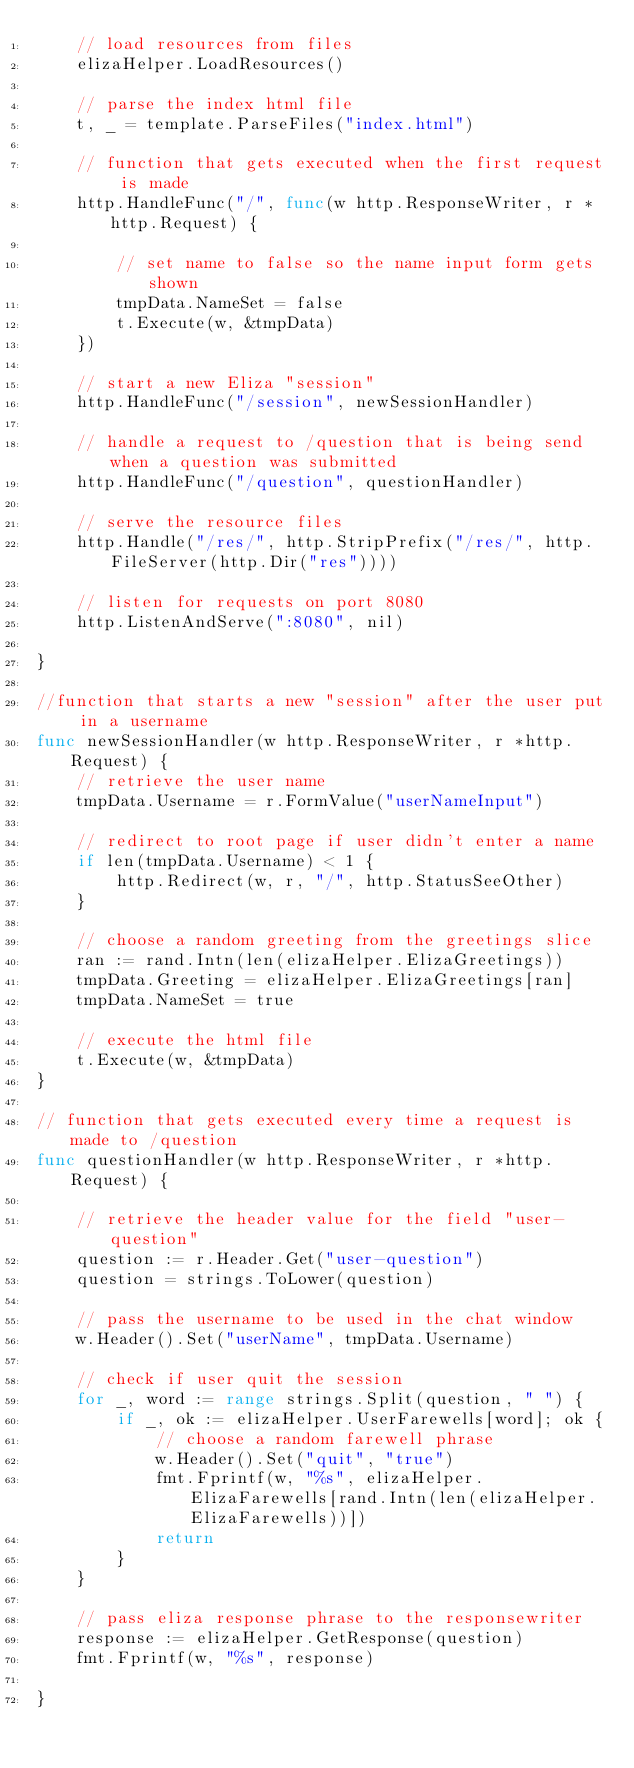Convert code to text. <code><loc_0><loc_0><loc_500><loc_500><_Go_>	// load resources from files
	elizaHelper.LoadResources()

	// parse the index html file
	t, _ = template.ParseFiles("index.html")

	// function that gets executed when the first request is made
	http.HandleFunc("/", func(w http.ResponseWriter, r *http.Request) {

		// set name to false so the name input form gets shown
		tmpData.NameSet = false
		t.Execute(w, &tmpData)
	})

	// start a new Eliza "session"
	http.HandleFunc("/session", newSessionHandler)

	// handle a request to /question that is being send when a question was submitted
	http.HandleFunc("/question", questionHandler)

	// serve the resource files
	http.Handle("/res/", http.StripPrefix("/res/", http.FileServer(http.Dir("res"))))

	// listen for requests on port 8080
	http.ListenAndServe(":8080", nil)

}

//function that starts a new "session" after the user put in a username
func newSessionHandler(w http.ResponseWriter, r *http.Request) {
	// retrieve the user name
	tmpData.Username = r.FormValue("userNameInput")

	// redirect to root page if user didn't enter a name
	if len(tmpData.Username) < 1 {
		http.Redirect(w, r, "/", http.StatusSeeOther)
	}

	// choose a random greeting from the greetings slice
	ran := rand.Intn(len(elizaHelper.ElizaGreetings))
	tmpData.Greeting = elizaHelper.ElizaGreetings[ran]
	tmpData.NameSet = true

	// execute the html file
	t.Execute(w, &tmpData)
}

// function that gets executed every time a request is made to /question
func questionHandler(w http.ResponseWriter, r *http.Request) {

	// retrieve the header value for the field "user-question"
	question := r.Header.Get("user-question")
	question = strings.ToLower(question)

	// pass the username to be used in the chat window
	w.Header().Set("userName", tmpData.Username)

	// check if user quit the session
	for _, word := range strings.Split(question, " ") {
		if _, ok := elizaHelper.UserFarewells[word]; ok {
			// choose a random farewell phrase
			w.Header().Set("quit", "true")
			fmt.Fprintf(w, "%s", elizaHelper.ElizaFarewells[rand.Intn(len(elizaHelper.ElizaFarewells))])
			return
		}
	}

	// pass eliza response phrase to the responsewriter
	response := elizaHelper.GetResponse(question)
	fmt.Fprintf(w, "%s", response)

}
</code> 